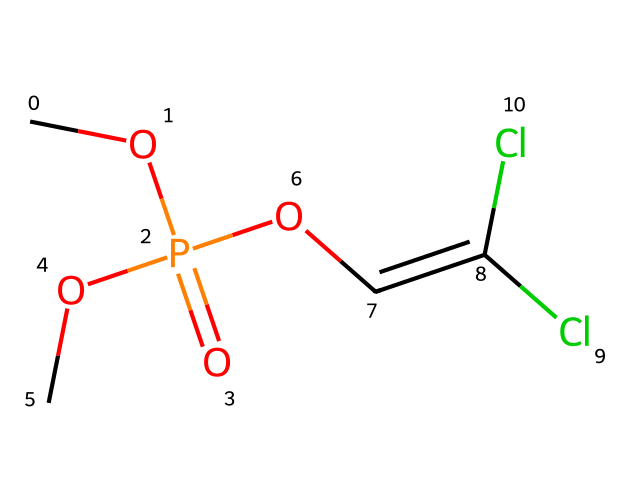how many chlorine atoms are in the molecular structure? By examining the SMILES representation, we can count the occurrences of "Cl," which indicates chlorine atoms. In this structure, "Cl" appears twice.
Answer: 2 what functional groups are present in dichlorvos? Looking at the structure and identifying groups, we see the presence of a phosphate group (P=O and O-R groups), an alkene (the C=C bond), and two chloro substituents (Cl). This indicates the functional groups present in the molecule.
Answer: phosphate, alkene, chloro what is the degree of unsaturation in dichlorvos? To calculate the degree of unsaturation, we consider the number of rings and double bonds. The presence of one double bond and no rings contributes one degree to unsaturation. Therefore, the degree of unsaturation is calculated based on the identified double bonds, which results in a total of one.
Answer: 1 is dichlorvos a solid, liquid, or gas at room temperature? Considering the properties of organophosphates and common uses, dichlorvos is typically known to be a liquid at room temperature, as advised in common safety materials and product descriptions.
Answer: liquid what class of pesticide does dichlorvos belong to? Given the molecular structure, it is apparent that dichlorvos belongs to the organophosphate class of pesticides, which are characterized by their phosphate groups and mode of action.
Answer: organophosphate how many total oxygen atoms are in the structure? On analyzing the SMILES representation, we find three occurrences of oxygen atoms (O). Each "O" in the phosphate and ether groups counts as one oxygen, totaling three.
Answer: 3 what is the significance of the double bond in the molecular structure? The double bond in the alkene part of the structure affects the reactive properties of the molecule, contributing to its biological activity as an insecticide, specifically altering the way it interacts with enzyme systems in pests.
Answer: biological activity 